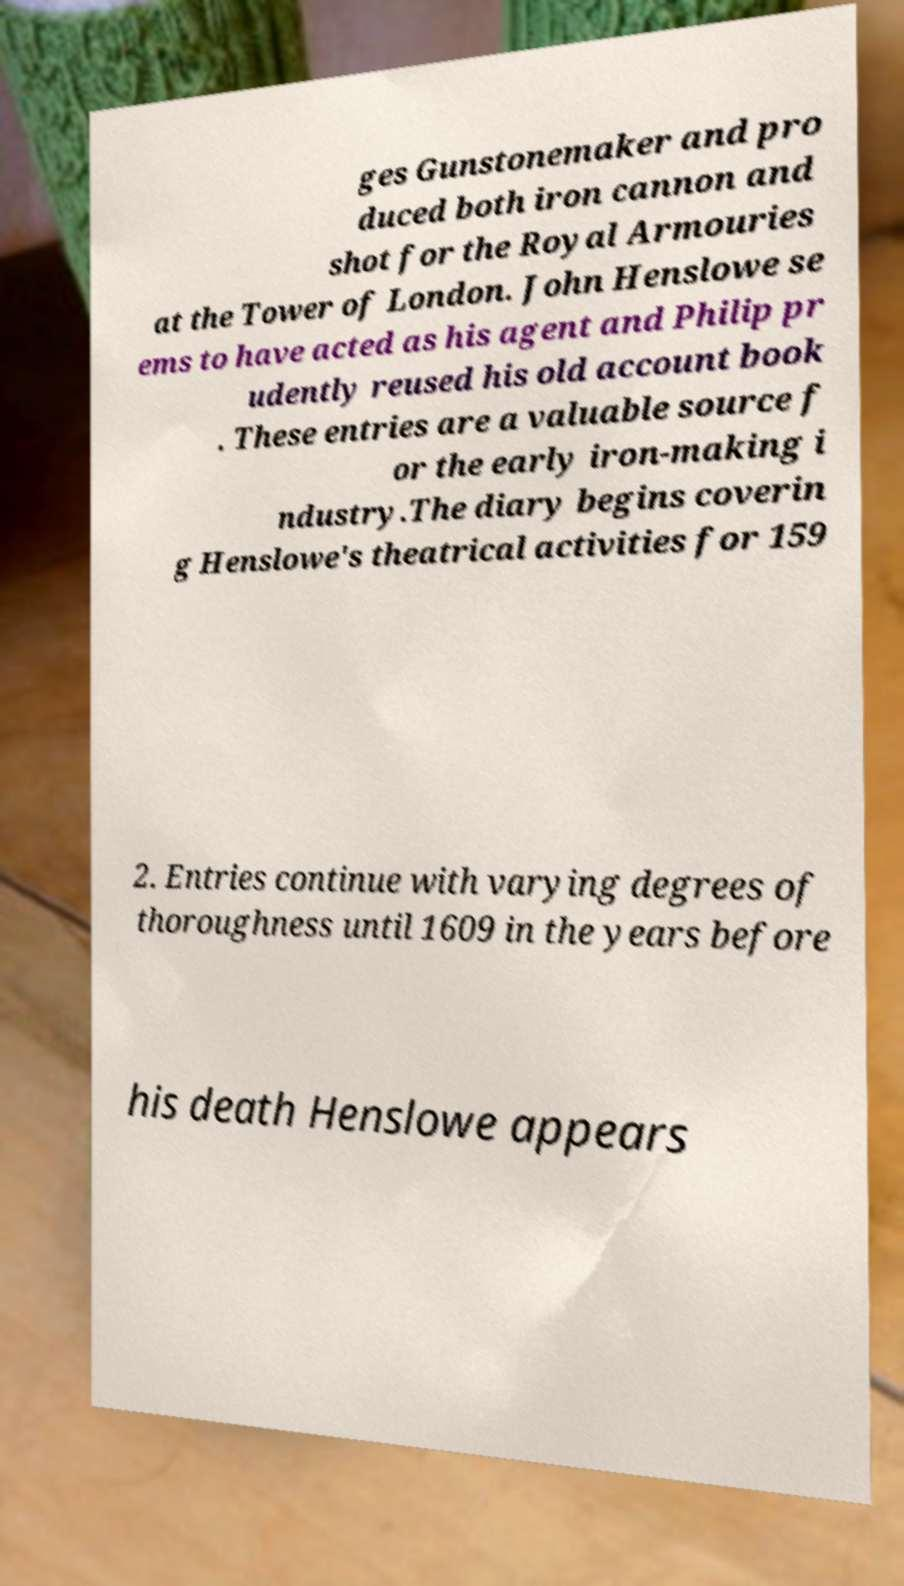For documentation purposes, I need the text within this image transcribed. Could you provide that? ges Gunstonemaker and pro duced both iron cannon and shot for the Royal Armouries at the Tower of London. John Henslowe se ems to have acted as his agent and Philip pr udently reused his old account book . These entries are a valuable source f or the early iron-making i ndustry.The diary begins coverin g Henslowe's theatrical activities for 159 2. Entries continue with varying degrees of thoroughness until 1609 in the years before his death Henslowe appears 